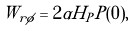<formula> <loc_0><loc_0><loc_500><loc_500>W _ { r \phi } = 2 \alpha H _ { P } P ( 0 ) ,</formula> 